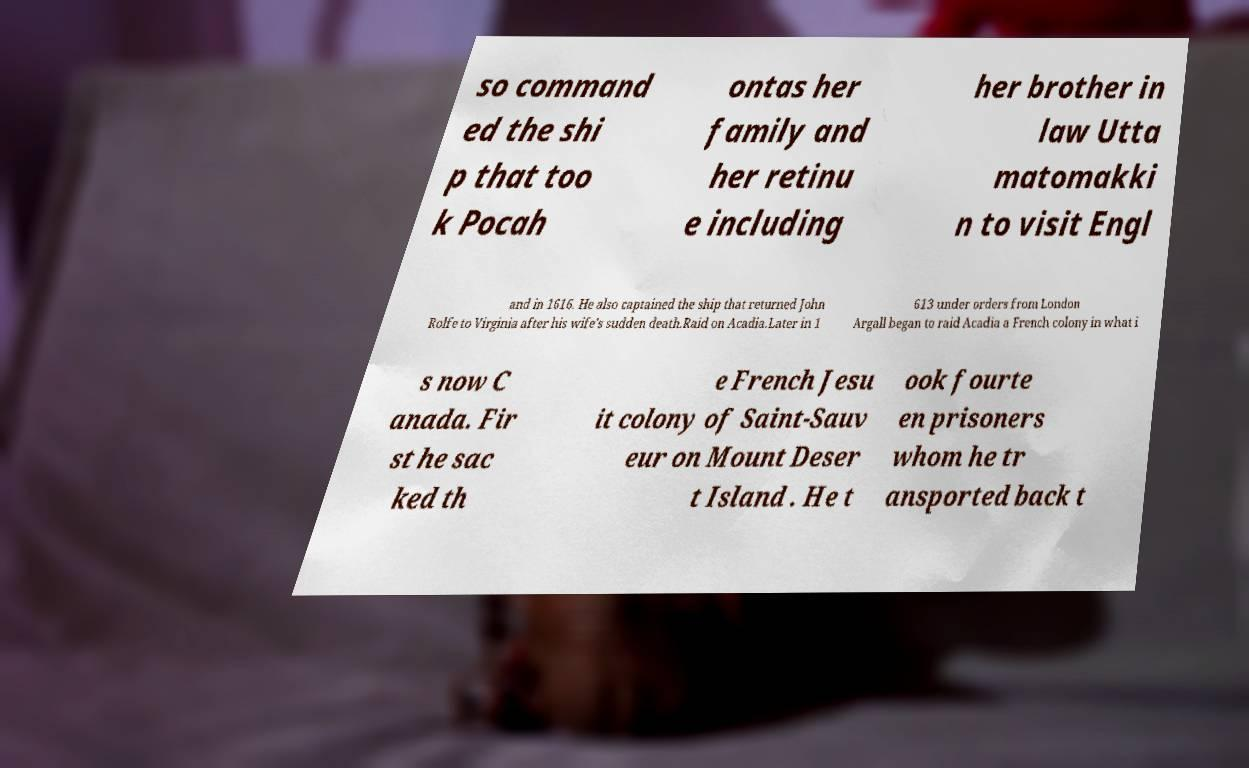I need the written content from this picture converted into text. Can you do that? so command ed the shi p that too k Pocah ontas her family and her retinu e including her brother in law Utta matomakki n to visit Engl and in 1616. He also captained the ship that returned John Rolfe to Virginia after his wife's sudden death.Raid on Acadia.Later in 1 613 under orders from London Argall began to raid Acadia a French colony in what i s now C anada. Fir st he sac ked th e French Jesu it colony of Saint-Sauv eur on Mount Deser t Island . He t ook fourte en prisoners whom he tr ansported back t 